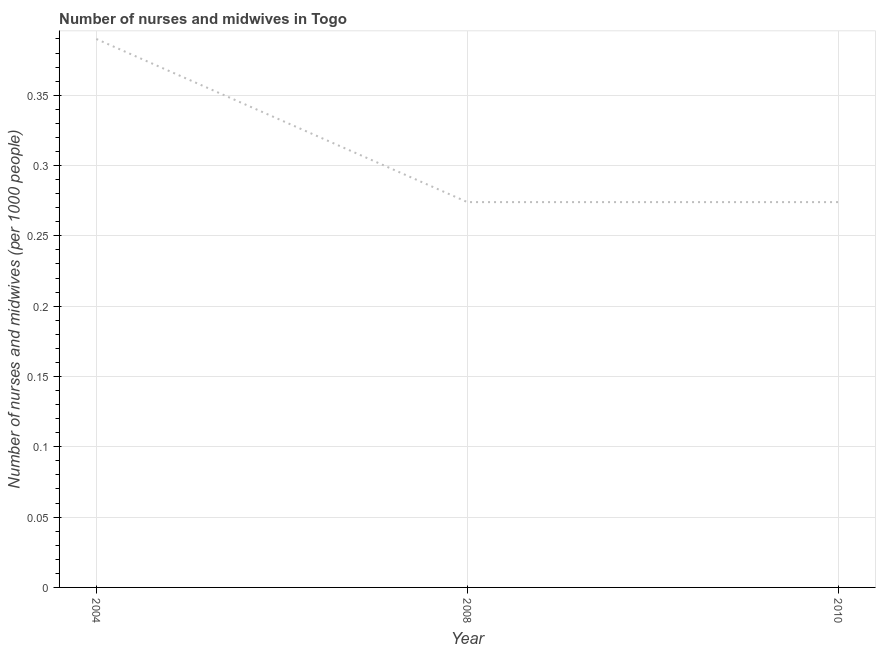What is the number of nurses and midwives in 2008?
Give a very brief answer. 0.27. Across all years, what is the maximum number of nurses and midwives?
Provide a succinct answer. 0.39. Across all years, what is the minimum number of nurses and midwives?
Offer a very short reply. 0.27. What is the sum of the number of nurses and midwives?
Keep it short and to the point. 0.94. What is the difference between the number of nurses and midwives in 2004 and 2010?
Keep it short and to the point. 0.12. What is the average number of nurses and midwives per year?
Give a very brief answer. 0.31. What is the median number of nurses and midwives?
Make the answer very short. 0.27. Do a majority of the years between 2010 and 2004 (inclusive) have number of nurses and midwives greater than 0.060000000000000005 ?
Offer a terse response. No. What is the ratio of the number of nurses and midwives in 2004 to that in 2010?
Offer a terse response. 1.42. Is the difference between the number of nurses and midwives in 2004 and 2008 greater than the difference between any two years?
Offer a very short reply. Yes. What is the difference between the highest and the second highest number of nurses and midwives?
Your response must be concise. 0.12. What is the difference between the highest and the lowest number of nurses and midwives?
Your answer should be very brief. 0.12. How many lines are there?
Provide a short and direct response. 1. How many years are there in the graph?
Make the answer very short. 3. Does the graph contain any zero values?
Ensure brevity in your answer.  No. What is the title of the graph?
Offer a very short reply. Number of nurses and midwives in Togo. What is the label or title of the X-axis?
Your response must be concise. Year. What is the label or title of the Y-axis?
Provide a short and direct response. Number of nurses and midwives (per 1000 people). What is the Number of nurses and midwives (per 1000 people) of 2004?
Offer a terse response. 0.39. What is the Number of nurses and midwives (per 1000 people) of 2008?
Your response must be concise. 0.27. What is the Number of nurses and midwives (per 1000 people) of 2010?
Make the answer very short. 0.27. What is the difference between the Number of nurses and midwives (per 1000 people) in 2004 and 2008?
Ensure brevity in your answer.  0.12. What is the difference between the Number of nurses and midwives (per 1000 people) in 2004 and 2010?
Your response must be concise. 0.12. What is the ratio of the Number of nurses and midwives (per 1000 people) in 2004 to that in 2008?
Ensure brevity in your answer.  1.42. What is the ratio of the Number of nurses and midwives (per 1000 people) in 2004 to that in 2010?
Your response must be concise. 1.42. 